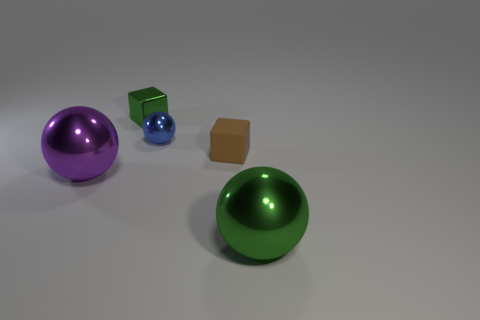Add 2 tiny blue rubber cylinders. How many objects exist? 7 Subtract all spheres. How many objects are left? 2 Add 4 big metal blocks. How many big metal blocks exist? 4 Subtract 1 green spheres. How many objects are left? 4 Subtract all small green things. Subtract all purple objects. How many objects are left? 3 Add 3 green cubes. How many green cubes are left? 4 